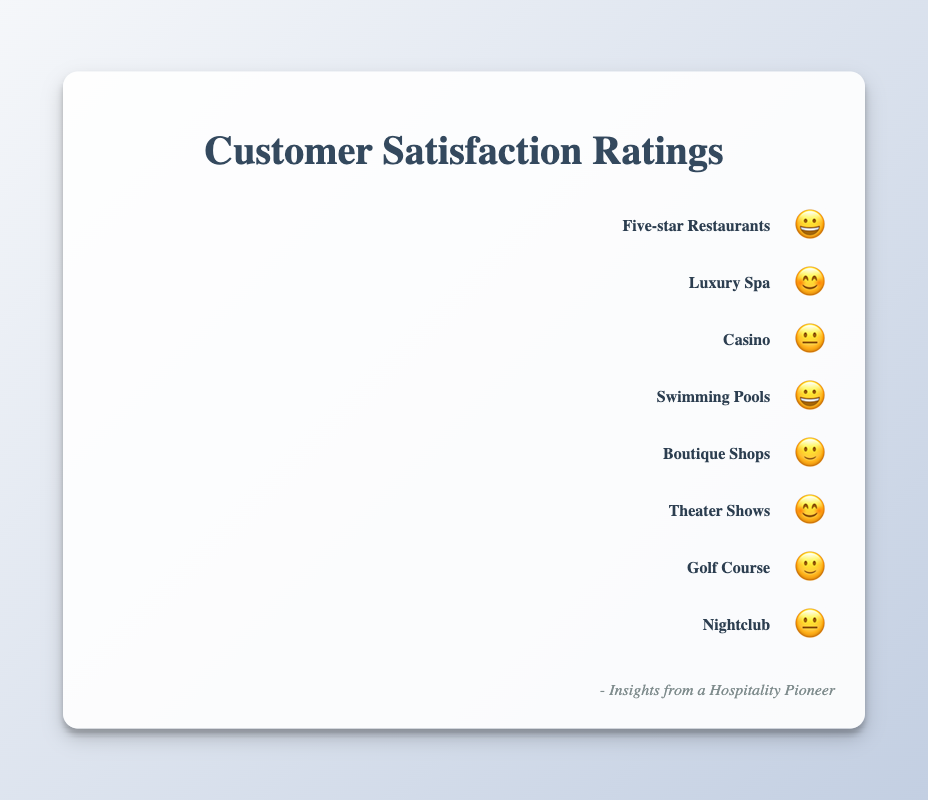Which amenity has the highest customer satisfaction rating? The amenities with the highest customer satisfaction rating have a 😃 (excited face) symbol. The Five-star Restaurants and Swimming Pools both have this rating. Therefore, both these amenities have the highest customer satisfaction rating.
Answer: Five-star Restaurants and Swimming Pools Which amenities have a "😊" (smiling face) satisfaction rating? Looking at the figure, the amenities with a "😊" (smiling face) satisfaction rating are Luxury Spa and Theater Shows.
Answer: Luxury Spa and Theater Shows How many amenities have a "😐" (neutral face) satisfaction rating? The amenities with a "😐" (neutral face) satisfaction rating are Casino and Nightclub. There are 2 amenities with this rating.
Answer: 2 Which amenity has the lowest customer satisfaction rating? The lowest customer satisfaction rating in the figure is indicated by the "😐" (neutral face) symbol. The amenities with this rating are Casino and Nightclub. Both of these amenities share the lowest rating.
Answer: Casino and Nightclub Which amenities are rated higher than the Casino? The Casino has a "😐" (neutral face) rating. We need to find amenities with "🙂" (slightly smiling), "😊" (smiling face), or "😃" (excited face) ratings. These amenities are Five-star Restaurants, Luxury Spa, Swimming Pools, Boutique Shops, Theater Shows, and Golf Course.
Answer: Five-star Restaurants, Luxury Spa, Swimming Pools, Boutique Shops, Theater Shows, and Golf Course What is the customer satisfaction rating for the Boutique Shops? The Boutique Shops have a rating of "🙂" (slightly smiling face) as indicated in the figure.
Answer: 🙂 Which amenities have a rating equal to or better than "😊" (smiling face)? The amenities rated "😊" (smiling face) or better (which includes "😊" and "😃") are Five-star Restaurants, Luxury Spa, Swimming Pools, and Theater Shows.
Answer: Five-star Restaurants, Luxury Spa, Swimming Pools, and Theater Shows Which amenity has equal customer satisfaction to the Nightclub? The Nightclub has a "😐" (neutral face) rating. The only other amenity with this same rating is the Casino.
Answer: Casino What is the overall distribution of satisfaction ratings among all amenities? To determine the distribution, count the number of amenities with each rating: "😃" - 2 (Five-star Restaurants, Swimming Pools), "😊" - 2 (Luxury Spa, Theater Shows), "🙂" - 2 (Boutique Shops, Golf Course), and "😐" - 2 (Casino, Nightclub). Therefore, the overall distribution is even across these ratings.
Answer: "😃": 2, "😊": 2, "🙂": 2, "😐": 2 